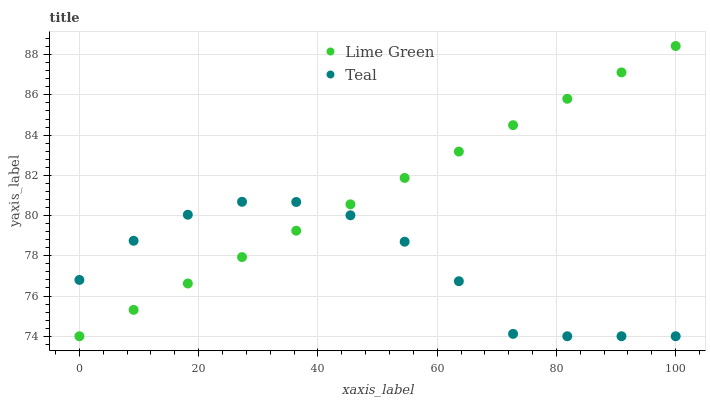Does Teal have the minimum area under the curve?
Answer yes or no. Yes. Does Lime Green have the maximum area under the curve?
Answer yes or no. Yes. Does Teal have the maximum area under the curve?
Answer yes or no. No. Is Lime Green the smoothest?
Answer yes or no. Yes. Is Teal the roughest?
Answer yes or no. Yes. Is Teal the smoothest?
Answer yes or no. No. Does Lime Green have the lowest value?
Answer yes or no. Yes. Does Lime Green have the highest value?
Answer yes or no. Yes. Does Teal have the highest value?
Answer yes or no. No. Does Teal intersect Lime Green?
Answer yes or no. Yes. Is Teal less than Lime Green?
Answer yes or no. No. Is Teal greater than Lime Green?
Answer yes or no. No. 